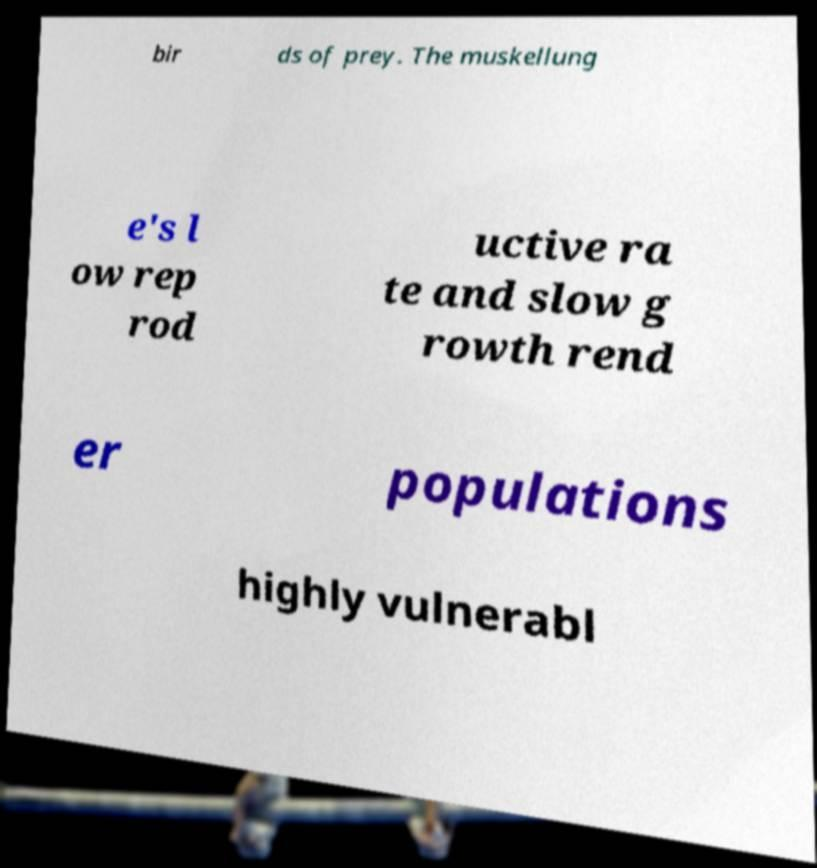For documentation purposes, I need the text within this image transcribed. Could you provide that? bir ds of prey. The muskellung e's l ow rep rod uctive ra te and slow g rowth rend er populations highly vulnerabl 